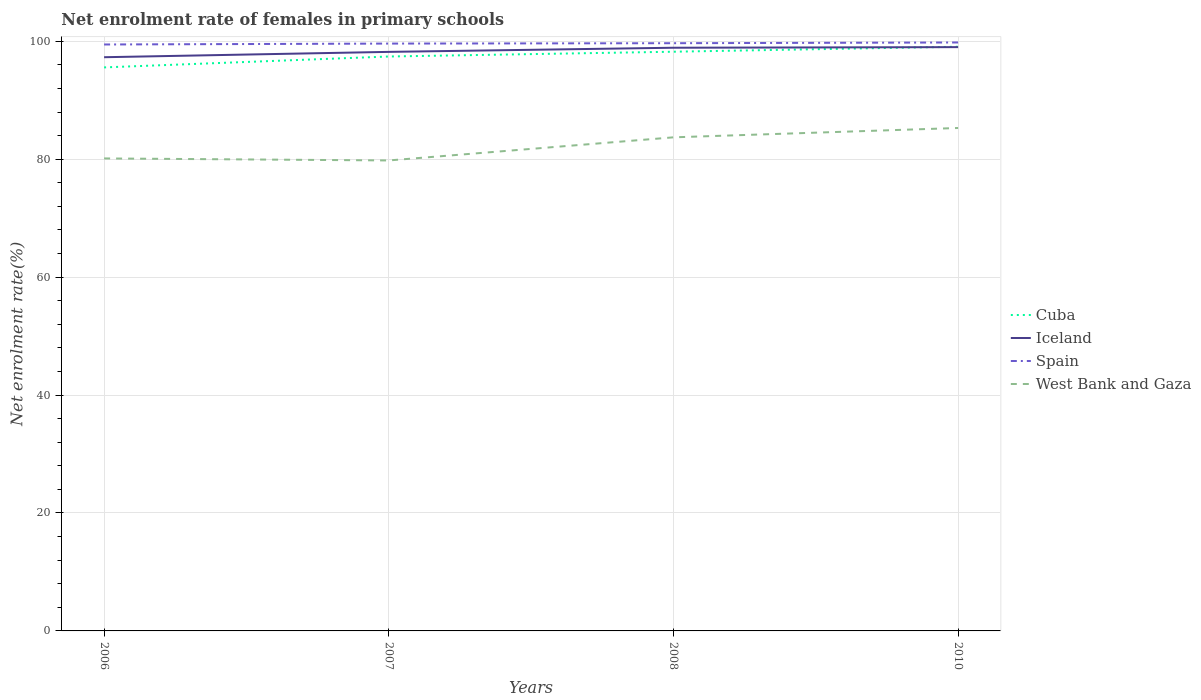How many different coloured lines are there?
Give a very brief answer. 4. Across all years, what is the maximum net enrolment rate of females in primary schools in Spain?
Provide a short and direct response. 99.45. What is the total net enrolment rate of females in primary schools in Iceland in the graph?
Your answer should be very brief. -1.61. What is the difference between the highest and the second highest net enrolment rate of females in primary schools in Spain?
Keep it short and to the point. 0.34. Is the net enrolment rate of females in primary schools in Iceland strictly greater than the net enrolment rate of females in primary schools in Cuba over the years?
Your response must be concise. No. How many lines are there?
Offer a terse response. 4. How many years are there in the graph?
Provide a short and direct response. 4. What is the difference between two consecutive major ticks on the Y-axis?
Make the answer very short. 20. Are the values on the major ticks of Y-axis written in scientific E-notation?
Make the answer very short. No. Does the graph contain grids?
Your answer should be compact. Yes. How many legend labels are there?
Provide a succinct answer. 4. What is the title of the graph?
Make the answer very short. Net enrolment rate of females in primary schools. What is the label or title of the Y-axis?
Your response must be concise. Net enrolment rate(%). What is the Net enrolment rate(%) in Cuba in 2006?
Offer a terse response. 95.57. What is the Net enrolment rate(%) of Iceland in 2006?
Offer a terse response. 97.29. What is the Net enrolment rate(%) of Spain in 2006?
Your answer should be compact. 99.45. What is the Net enrolment rate(%) in West Bank and Gaza in 2006?
Offer a very short reply. 80.13. What is the Net enrolment rate(%) in Cuba in 2007?
Your answer should be very brief. 97.42. What is the Net enrolment rate(%) of Iceland in 2007?
Provide a succinct answer. 98.2. What is the Net enrolment rate(%) of Spain in 2007?
Provide a short and direct response. 99.61. What is the Net enrolment rate(%) in West Bank and Gaza in 2007?
Your response must be concise. 79.79. What is the Net enrolment rate(%) of Cuba in 2008?
Give a very brief answer. 98.23. What is the Net enrolment rate(%) in Iceland in 2008?
Offer a terse response. 98.9. What is the Net enrolment rate(%) of Spain in 2008?
Provide a short and direct response. 99.67. What is the Net enrolment rate(%) of West Bank and Gaza in 2008?
Your response must be concise. 83.71. What is the Net enrolment rate(%) in Cuba in 2010?
Offer a very short reply. 99.07. What is the Net enrolment rate(%) in Iceland in 2010?
Keep it short and to the point. 99.01. What is the Net enrolment rate(%) of Spain in 2010?
Ensure brevity in your answer.  99.79. What is the Net enrolment rate(%) of West Bank and Gaza in 2010?
Keep it short and to the point. 85.29. Across all years, what is the maximum Net enrolment rate(%) in Cuba?
Provide a succinct answer. 99.07. Across all years, what is the maximum Net enrolment rate(%) of Iceland?
Your answer should be compact. 99.01. Across all years, what is the maximum Net enrolment rate(%) in Spain?
Keep it short and to the point. 99.79. Across all years, what is the maximum Net enrolment rate(%) in West Bank and Gaza?
Make the answer very short. 85.29. Across all years, what is the minimum Net enrolment rate(%) in Cuba?
Offer a terse response. 95.57. Across all years, what is the minimum Net enrolment rate(%) in Iceland?
Keep it short and to the point. 97.29. Across all years, what is the minimum Net enrolment rate(%) in Spain?
Ensure brevity in your answer.  99.45. Across all years, what is the minimum Net enrolment rate(%) of West Bank and Gaza?
Give a very brief answer. 79.79. What is the total Net enrolment rate(%) in Cuba in the graph?
Your response must be concise. 390.28. What is the total Net enrolment rate(%) of Iceland in the graph?
Your response must be concise. 393.4. What is the total Net enrolment rate(%) in Spain in the graph?
Your response must be concise. 398.53. What is the total Net enrolment rate(%) of West Bank and Gaza in the graph?
Provide a succinct answer. 328.92. What is the difference between the Net enrolment rate(%) in Cuba in 2006 and that in 2007?
Give a very brief answer. -1.85. What is the difference between the Net enrolment rate(%) in Iceland in 2006 and that in 2007?
Offer a very short reply. -0.91. What is the difference between the Net enrolment rate(%) in Spain in 2006 and that in 2007?
Provide a succinct answer. -0.15. What is the difference between the Net enrolment rate(%) in West Bank and Gaza in 2006 and that in 2007?
Make the answer very short. 0.34. What is the difference between the Net enrolment rate(%) in Cuba in 2006 and that in 2008?
Provide a succinct answer. -2.66. What is the difference between the Net enrolment rate(%) of Iceland in 2006 and that in 2008?
Ensure brevity in your answer.  -1.61. What is the difference between the Net enrolment rate(%) in Spain in 2006 and that in 2008?
Make the answer very short. -0.22. What is the difference between the Net enrolment rate(%) of West Bank and Gaza in 2006 and that in 2008?
Your answer should be very brief. -3.58. What is the difference between the Net enrolment rate(%) in Cuba in 2006 and that in 2010?
Keep it short and to the point. -3.51. What is the difference between the Net enrolment rate(%) in Iceland in 2006 and that in 2010?
Offer a very short reply. -1.71. What is the difference between the Net enrolment rate(%) of Spain in 2006 and that in 2010?
Your answer should be very brief. -0.34. What is the difference between the Net enrolment rate(%) in West Bank and Gaza in 2006 and that in 2010?
Provide a succinct answer. -5.16. What is the difference between the Net enrolment rate(%) of Cuba in 2007 and that in 2008?
Your response must be concise. -0.81. What is the difference between the Net enrolment rate(%) in Iceland in 2007 and that in 2008?
Offer a terse response. -0.7. What is the difference between the Net enrolment rate(%) of Spain in 2007 and that in 2008?
Offer a terse response. -0.06. What is the difference between the Net enrolment rate(%) in West Bank and Gaza in 2007 and that in 2008?
Your answer should be compact. -3.92. What is the difference between the Net enrolment rate(%) of Cuba in 2007 and that in 2010?
Your answer should be compact. -1.66. What is the difference between the Net enrolment rate(%) in Iceland in 2007 and that in 2010?
Offer a terse response. -0.81. What is the difference between the Net enrolment rate(%) in Spain in 2007 and that in 2010?
Make the answer very short. -0.19. What is the difference between the Net enrolment rate(%) in West Bank and Gaza in 2007 and that in 2010?
Offer a terse response. -5.51. What is the difference between the Net enrolment rate(%) in Cuba in 2008 and that in 2010?
Offer a terse response. -0.84. What is the difference between the Net enrolment rate(%) in Iceland in 2008 and that in 2010?
Your response must be concise. -0.1. What is the difference between the Net enrolment rate(%) of Spain in 2008 and that in 2010?
Keep it short and to the point. -0.12. What is the difference between the Net enrolment rate(%) of West Bank and Gaza in 2008 and that in 2010?
Provide a succinct answer. -1.59. What is the difference between the Net enrolment rate(%) in Cuba in 2006 and the Net enrolment rate(%) in Iceland in 2007?
Provide a succinct answer. -2.63. What is the difference between the Net enrolment rate(%) in Cuba in 2006 and the Net enrolment rate(%) in Spain in 2007?
Your response must be concise. -4.04. What is the difference between the Net enrolment rate(%) in Cuba in 2006 and the Net enrolment rate(%) in West Bank and Gaza in 2007?
Give a very brief answer. 15.78. What is the difference between the Net enrolment rate(%) of Iceland in 2006 and the Net enrolment rate(%) of Spain in 2007?
Provide a short and direct response. -2.31. What is the difference between the Net enrolment rate(%) in Iceland in 2006 and the Net enrolment rate(%) in West Bank and Gaza in 2007?
Provide a succinct answer. 17.51. What is the difference between the Net enrolment rate(%) in Spain in 2006 and the Net enrolment rate(%) in West Bank and Gaza in 2007?
Your response must be concise. 19.67. What is the difference between the Net enrolment rate(%) of Cuba in 2006 and the Net enrolment rate(%) of Iceland in 2008?
Your answer should be compact. -3.34. What is the difference between the Net enrolment rate(%) of Cuba in 2006 and the Net enrolment rate(%) of Spain in 2008?
Offer a very short reply. -4.1. What is the difference between the Net enrolment rate(%) of Cuba in 2006 and the Net enrolment rate(%) of West Bank and Gaza in 2008?
Ensure brevity in your answer.  11.86. What is the difference between the Net enrolment rate(%) in Iceland in 2006 and the Net enrolment rate(%) in Spain in 2008?
Keep it short and to the point. -2.38. What is the difference between the Net enrolment rate(%) of Iceland in 2006 and the Net enrolment rate(%) of West Bank and Gaza in 2008?
Provide a succinct answer. 13.59. What is the difference between the Net enrolment rate(%) of Spain in 2006 and the Net enrolment rate(%) of West Bank and Gaza in 2008?
Keep it short and to the point. 15.74. What is the difference between the Net enrolment rate(%) in Cuba in 2006 and the Net enrolment rate(%) in Iceland in 2010?
Make the answer very short. -3.44. What is the difference between the Net enrolment rate(%) of Cuba in 2006 and the Net enrolment rate(%) of Spain in 2010?
Make the answer very short. -4.23. What is the difference between the Net enrolment rate(%) in Cuba in 2006 and the Net enrolment rate(%) in West Bank and Gaza in 2010?
Provide a succinct answer. 10.27. What is the difference between the Net enrolment rate(%) in Iceland in 2006 and the Net enrolment rate(%) in Spain in 2010?
Your answer should be compact. -2.5. What is the difference between the Net enrolment rate(%) of Iceland in 2006 and the Net enrolment rate(%) of West Bank and Gaza in 2010?
Provide a short and direct response. 12. What is the difference between the Net enrolment rate(%) of Spain in 2006 and the Net enrolment rate(%) of West Bank and Gaza in 2010?
Offer a very short reply. 14.16. What is the difference between the Net enrolment rate(%) of Cuba in 2007 and the Net enrolment rate(%) of Iceland in 2008?
Provide a succinct answer. -1.49. What is the difference between the Net enrolment rate(%) of Cuba in 2007 and the Net enrolment rate(%) of Spain in 2008?
Your answer should be compact. -2.26. What is the difference between the Net enrolment rate(%) of Cuba in 2007 and the Net enrolment rate(%) of West Bank and Gaza in 2008?
Provide a short and direct response. 13.71. What is the difference between the Net enrolment rate(%) in Iceland in 2007 and the Net enrolment rate(%) in Spain in 2008?
Your response must be concise. -1.47. What is the difference between the Net enrolment rate(%) of Iceland in 2007 and the Net enrolment rate(%) of West Bank and Gaza in 2008?
Your response must be concise. 14.49. What is the difference between the Net enrolment rate(%) in Spain in 2007 and the Net enrolment rate(%) in West Bank and Gaza in 2008?
Your answer should be very brief. 15.9. What is the difference between the Net enrolment rate(%) of Cuba in 2007 and the Net enrolment rate(%) of Iceland in 2010?
Offer a terse response. -1.59. What is the difference between the Net enrolment rate(%) of Cuba in 2007 and the Net enrolment rate(%) of Spain in 2010?
Offer a terse response. -2.38. What is the difference between the Net enrolment rate(%) of Cuba in 2007 and the Net enrolment rate(%) of West Bank and Gaza in 2010?
Make the answer very short. 12.12. What is the difference between the Net enrolment rate(%) of Iceland in 2007 and the Net enrolment rate(%) of Spain in 2010?
Give a very brief answer. -1.59. What is the difference between the Net enrolment rate(%) in Iceland in 2007 and the Net enrolment rate(%) in West Bank and Gaza in 2010?
Your response must be concise. 12.91. What is the difference between the Net enrolment rate(%) of Spain in 2007 and the Net enrolment rate(%) of West Bank and Gaza in 2010?
Offer a very short reply. 14.31. What is the difference between the Net enrolment rate(%) of Cuba in 2008 and the Net enrolment rate(%) of Iceland in 2010?
Provide a succinct answer. -0.78. What is the difference between the Net enrolment rate(%) of Cuba in 2008 and the Net enrolment rate(%) of Spain in 2010?
Your answer should be compact. -1.57. What is the difference between the Net enrolment rate(%) of Cuba in 2008 and the Net enrolment rate(%) of West Bank and Gaza in 2010?
Keep it short and to the point. 12.93. What is the difference between the Net enrolment rate(%) of Iceland in 2008 and the Net enrolment rate(%) of Spain in 2010?
Offer a very short reply. -0.89. What is the difference between the Net enrolment rate(%) of Iceland in 2008 and the Net enrolment rate(%) of West Bank and Gaza in 2010?
Make the answer very short. 13.61. What is the difference between the Net enrolment rate(%) in Spain in 2008 and the Net enrolment rate(%) in West Bank and Gaza in 2010?
Offer a terse response. 14.38. What is the average Net enrolment rate(%) in Cuba per year?
Offer a very short reply. 97.57. What is the average Net enrolment rate(%) in Iceland per year?
Keep it short and to the point. 98.35. What is the average Net enrolment rate(%) in Spain per year?
Offer a very short reply. 99.63. What is the average Net enrolment rate(%) in West Bank and Gaza per year?
Give a very brief answer. 82.23. In the year 2006, what is the difference between the Net enrolment rate(%) in Cuba and Net enrolment rate(%) in Iceland?
Ensure brevity in your answer.  -1.73. In the year 2006, what is the difference between the Net enrolment rate(%) of Cuba and Net enrolment rate(%) of Spain?
Make the answer very short. -3.89. In the year 2006, what is the difference between the Net enrolment rate(%) in Cuba and Net enrolment rate(%) in West Bank and Gaza?
Your response must be concise. 15.44. In the year 2006, what is the difference between the Net enrolment rate(%) of Iceland and Net enrolment rate(%) of Spain?
Your response must be concise. -2.16. In the year 2006, what is the difference between the Net enrolment rate(%) in Iceland and Net enrolment rate(%) in West Bank and Gaza?
Provide a succinct answer. 17.16. In the year 2006, what is the difference between the Net enrolment rate(%) of Spain and Net enrolment rate(%) of West Bank and Gaza?
Provide a succinct answer. 19.32. In the year 2007, what is the difference between the Net enrolment rate(%) in Cuba and Net enrolment rate(%) in Iceland?
Ensure brevity in your answer.  -0.79. In the year 2007, what is the difference between the Net enrolment rate(%) of Cuba and Net enrolment rate(%) of Spain?
Keep it short and to the point. -2.19. In the year 2007, what is the difference between the Net enrolment rate(%) in Cuba and Net enrolment rate(%) in West Bank and Gaza?
Your response must be concise. 17.63. In the year 2007, what is the difference between the Net enrolment rate(%) in Iceland and Net enrolment rate(%) in Spain?
Your answer should be very brief. -1.41. In the year 2007, what is the difference between the Net enrolment rate(%) of Iceland and Net enrolment rate(%) of West Bank and Gaza?
Provide a succinct answer. 18.41. In the year 2007, what is the difference between the Net enrolment rate(%) in Spain and Net enrolment rate(%) in West Bank and Gaza?
Provide a succinct answer. 19.82. In the year 2008, what is the difference between the Net enrolment rate(%) in Cuba and Net enrolment rate(%) in Iceland?
Your answer should be compact. -0.67. In the year 2008, what is the difference between the Net enrolment rate(%) in Cuba and Net enrolment rate(%) in Spain?
Your answer should be compact. -1.44. In the year 2008, what is the difference between the Net enrolment rate(%) in Cuba and Net enrolment rate(%) in West Bank and Gaza?
Offer a very short reply. 14.52. In the year 2008, what is the difference between the Net enrolment rate(%) in Iceland and Net enrolment rate(%) in Spain?
Provide a succinct answer. -0.77. In the year 2008, what is the difference between the Net enrolment rate(%) of Iceland and Net enrolment rate(%) of West Bank and Gaza?
Your response must be concise. 15.19. In the year 2008, what is the difference between the Net enrolment rate(%) in Spain and Net enrolment rate(%) in West Bank and Gaza?
Give a very brief answer. 15.96. In the year 2010, what is the difference between the Net enrolment rate(%) of Cuba and Net enrolment rate(%) of Iceland?
Your answer should be compact. 0.07. In the year 2010, what is the difference between the Net enrolment rate(%) of Cuba and Net enrolment rate(%) of Spain?
Your response must be concise. -0.72. In the year 2010, what is the difference between the Net enrolment rate(%) in Cuba and Net enrolment rate(%) in West Bank and Gaza?
Provide a short and direct response. 13.78. In the year 2010, what is the difference between the Net enrolment rate(%) in Iceland and Net enrolment rate(%) in Spain?
Your response must be concise. -0.79. In the year 2010, what is the difference between the Net enrolment rate(%) of Iceland and Net enrolment rate(%) of West Bank and Gaza?
Keep it short and to the point. 13.71. In the year 2010, what is the difference between the Net enrolment rate(%) in Spain and Net enrolment rate(%) in West Bank and Gaza?
Keep it short and to the point. 14.5. What is the ratio of the Net enrolment rate(%) in West Bank and Gaza in 2006 to that in 2007?
Your answer should be compact. 1. What is the ratio of the Net enrolment rate(%) of Cuba in 2006 to that in 2008?
Your answer should be very brief. 0.97. What is the ratio of the Net enrolment rate(%) in Iceland in 2006 to that in 2008?
Ensure brevity in your answer.  0.98. What is the ratio of the Net enrolment rate(%) of West Bank and Gaza in 2006 to that in 2008?
Your response must be concise. 0.96. What is the ratio of the Net enrolment rate(%) in Cuba in 2006 to that in 2010?
Ensure brevity in your answer.  0.96. What is the ratio of the Net enrolment rate(%) of Iceland in 2006 to that in 2010?
Ensure brevity in your answer.  0.98. What is the ratio of the Net enrolment rate(%) of West Bank and Gaza in 2006 to that in 2010?
Keep it short and to the point. 0.94. What is the ratio of the Net enrolment rate(%) of Iceland in 2007 to that in 2008?
Offer a terse response. 0.99. What is the ratio of the Net enrolment rate(%) in Spain in 2007 to that in 2008?
Your answer should be compact. 1. What is the ratio of the Net enrolment rate(%) of West Bank and Gaza in 2007 to that in 2008?
Provide a short and direct response. 0.95. What is the ratio of the Net enrolment rate(%) of Cuba in 2007 to that in 2010?
Offer a very short reply. 0.98. What is the ratio of the Net enrolment rate(%) of West Bank and Gaza in 2007 to that in 2010?
Make the answer very short. 0.94. What is the ratio of the Net enrolment rate(%) in Iceland in 2008 to that in 2010?
Offer a terse response. 1. What is the ratio of the Net enrolment rate(%) in Spain in 2008 to that in 2010?
Keep it short and to the point. 1. What is the ratio of the Net enrolment rate(%) of West Bank and Gaza in 2008 to that in 2010?
Provide a short and direct response. 0.98. What is the difference between the highest and the second highest Net enrolment rate(%) in Cuba?
Keep it short and to the point. 0.84. What is the difference between the highest and the second highest Net enrolment rate(%) in Iceland?
Offer a terse response. 0.1. What is the difference between the highest and the second highest Net enrolment rate(%) in Spain?
Make the answer very short. 0.12. What is the difference between the highest and the second highest Net enrolment rate(%) in West Bank and Gaza?
Offer a terse response. 1.59. What is the difference between the highest and the lowest Net enrolment rate(%) of Cuba?
Make the answer very short. 3.51. What is the difference between the highest and the lowest Net enrolment rate(%) in Iceland?
Ensure brevity in your answer.  1.71. What is the difference between the highest and the lowest Net enrolment rate(%) in Spain?
Your answer should be very brief. 0.34. What is the difference between the highest and the lowest Net enrolment rate(%) in West Bank and Gaza?
Offer a terse response. 5.51. 